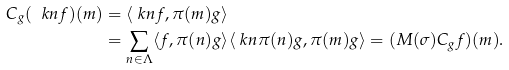<formula> <loc_0><loc_0><loc_500><loc_500>C _ { g } ( \ k n f ) ( m ) & = \langle \ k n f , \pi ( m ) g \rangle \\ & = \sum _ { n \in \Lambda } \langle f , \pi ( n ) g \rangle \langle \ k n \pi ( n ) g , \pi ( m ) g \rangle = ( M ( \sigma ) C _ { g } f ) ( m ) .</formula> 